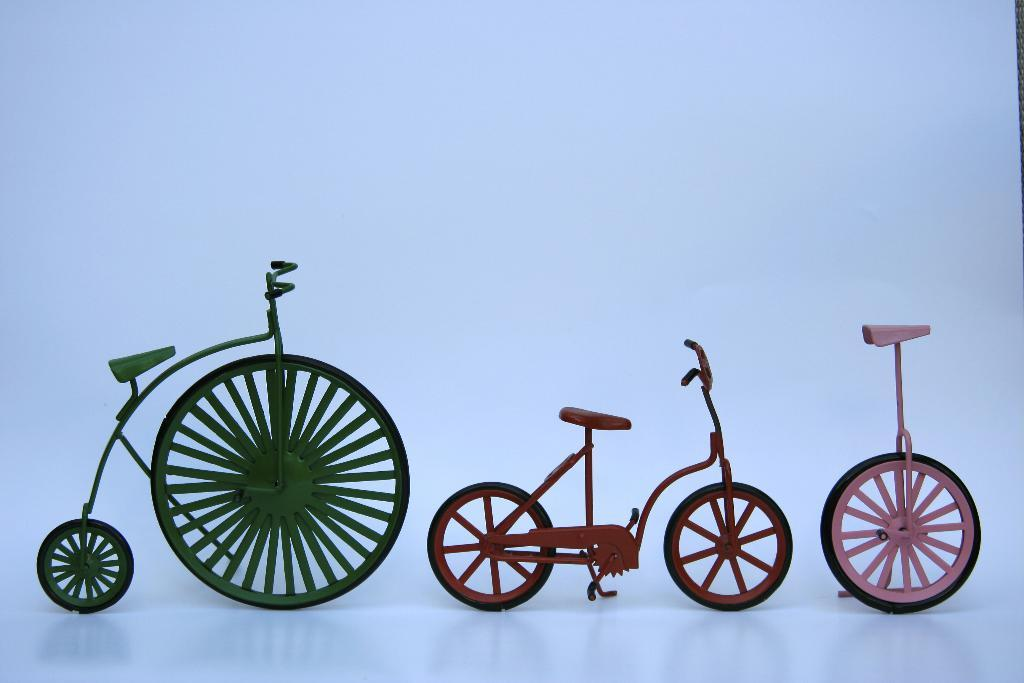What types of vehicles are depicted as showpieces in the image? There are showpieces of two bicycles and one unicycle in the image. What is the color of the surface beneath the showpieces? The surface beneath the showpieces is white in color. What type of quill can be seen in the image? There is no quill present in the image. How many stars are visible in the image? There are no stars visible in the image. 